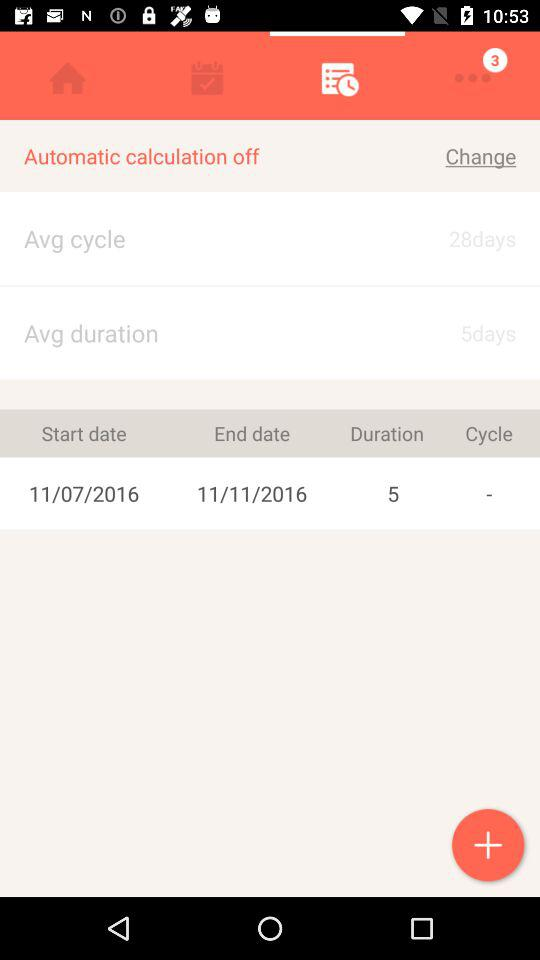How many days are in the average cycle? There are 28 days in the average cycle. 